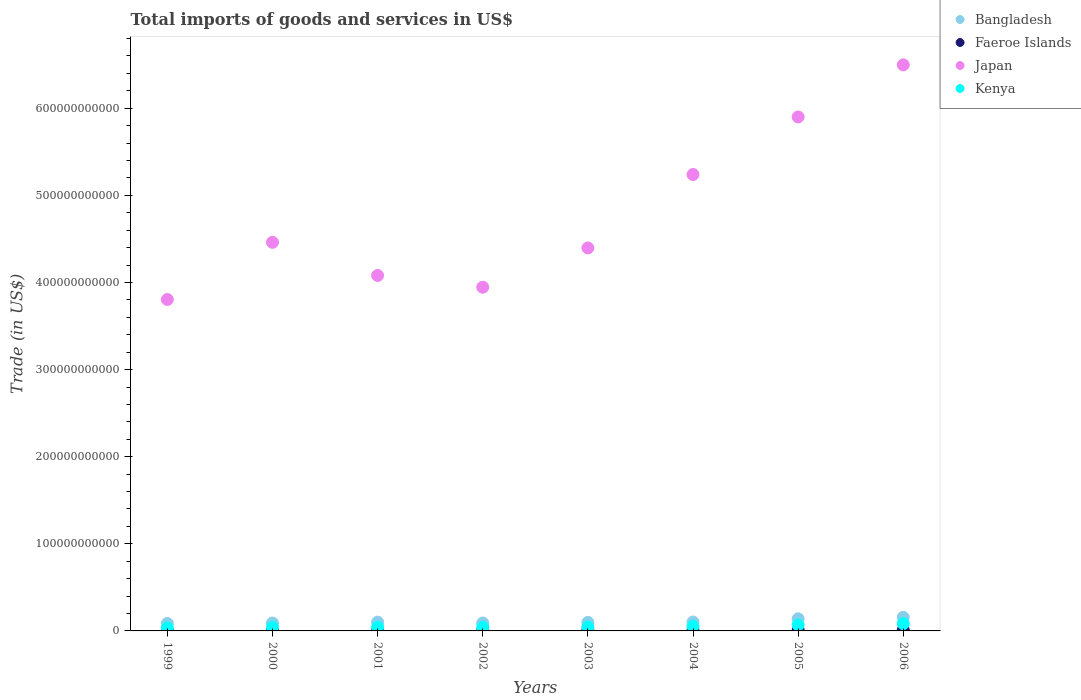What is the total imports of goods and services in Faeroe Islands in 2001?
Provide a succinct answer. 5.85e+08. Across all years, what is the maximum total imports of goods and services in Faeroe Islands?
Provide a succinct answer. 1.03e+09. Across all years, what is the minimum total imports of goods and services in Faeroe Islands?
Your response must be concise. 5.60e+08. In which year was the total imports of goods and services in Bangladesh maximum?
Provide a short and direct response. 2006. What is the total total imports of goods and services in Kenya in the graph?
Ensure brevity in your answer.  4.07e+1. What is the difference between the total imports of goods and services in Bangladesh in 1999 and that in 2000?
Your response must be concise. -5.35e+08. What is the difference between the total imports of goods and services in Japan in 2002 and the total imports of goods and services in Bangladesh in 2005?
Your response must be concise. 3.81e+11. What is the average total imports of goods and services in Kenya per year?
Make the answer very short. 5.08e+09. In the year 2003, what is the difference between the total imports of goods and services in Kenya and total imports of goods and services in Faeroe Islands?
Your response must be concise. 3.61e+09. In how many years, is the total imports of goods and services in Faeroe Islands greater than 560000000000 US$?
Make the answer very short. 0. What is the ratio of the total imports of goods and services in Kenya in 2002 to that in 2006?
Your answer should be compact. 0.48. Is the total imports of goods and services in Japan in 2001 less than that in 2005?
Provide a succinct answer. Yes. What is the difference between the highest and the second highest total imports of goods and services in Kenya?
Your response must be concise. 1.59e+09. What is the difference between the highest and the lowest total imports of goods and services in Japan?
Provide a succinct answer. 2.69e+11. Is the sum of the total imports of goods and services in Japan in 1999 and 2003 greater than the maximum total imports of goods and services in Kenya across all years?
Provide a short and direct response. Yes. Is it the case that in every year, the sum of the total imports of goods and services in Japan and total imports of goods and services in Faeroe Islands  is greater than the total imports of goods and services in Kenya?
Offer a terse response. Yes. Is the total imports of goods and services in Bangladesh strictly greater than the total imports of goods and services in Faeroe Islands over the years?
Give a very brief answer. Yes. How many dotlines are there?
Keep it short and to the point. 4. How many years are there in the graph?
Offer a very short reply. 8. What is the difference between two consecutive major ticks on the Y-axis?
Offer a terse response. 1.00e+11. Are the values on the major ticks of Y-axis written in scientific E-notation?
Your answer should be compact. No. Does the graph contain any zero values?
Give a very brief answer. No. How many legend labels are there?
Your response must be concise. 4. How are the legend labels stacked?
Offer a terse response. Vertical. What is the title of the graph?
Your answer should be compact. Total imports of goods and services in US$. Does "Uganda" appear as one of the legend labels in the graph?
Give a very brief answer. No. What is the label or title of the Y-axis?
Make the answer very short. Trade (in US$). What is the Trade (in US$) of Bangladesh in 1999?
Provide a succinct answer. 8.53e+09. What is the Trade (in US$) of Faeroe Islands in 1999?
Ensure brevity in your answer.  5.60e+08. What is the Trade (in US$) of Japan in 1999?
Your answer should be very brief. 3.80e+11. What is the Trade (in US$) in Kenya in 1999?
Provide a succinct answer. 3.53e+09. What is the Trade (in US$) in Bangladesh in 2000?
Provide a succinct answer. 9.06e+09. What is the Trade (in US$) of Faeroe Islands in 2000?
Your answer should be compact. 6.11e+08. What is the Trade (in US$) of Japan in 2000?
Your response must be concise. 4.46e+11. What is the Trade (in US$) of Kenya in 2000?
Keep it short and to the point. 4.03e+09. What is the Trade (in US$) in Bangladesh in 2001?
Ensure brevity in your answer.  1.01e+1. What is the Trade (in US$) in Faeroe Islands in 2001?
Keep it short and to the point. 5.85e+08. What is the Trade (in US$) of Japan in 2001?
Provide a succinct answer. 4.08e+11. What is the Trade (in US$) of Kenya in 2001?
Offer a very short reply. 4.29e+09. What is the Trade (in US$) of Bangladesh in 2002?
Your answer should be very brief. 9.06e+09. What is the Trade (in US$) of Faeroe Islands in 2002?
Provide a short and direct response. 6.11e+08. What is the Trade (in US$) in Japan in 2002?
Ensure brevity in your answer.  3.95e+11. What is the Trade (in US$) in Kenya in 2002?
Provide a succinct answer. 3.98e+09. What is the Trade (in US$) in Bangladesh in 2003?
Keep it short and to the point. 9.76e+09. What is the Trade (in US$) in Faeroe Islands in 2003?
Give a very brief answer. 8.70e+08. What is the Trade (in US$) of Japan in 2003?
Your answer should be compact. 4.40e+11. What is the Trade (in US$) of Kenya in 2003?
Keep it short and to the point. 4.48e+09. What is the Trade (in US$) in Bangladesh in 2004?
Provide a succinct answer. 1.02e+1. What is the Trade (in US$) of Faeroe Islands in 2004?
Your answer should be very brief. 7.70e+08. What is the Trade (in US$) of Japan in 2004?
Your answer should be very brief. 5.24e+11. What is the Trade (in US$) of Kenya in 2004?
Give a very brief answer. 5.29e+09. What is the Trade (in US$) in Bangladesh in 2005?
Your answer should be very brief. 1.39e+1. What is the Trade (in US$) in Faeroe Islands in 2005?
Offer a terse response. 9.09e+08. What is the Trade (in US$) of Japan in 2005?
Give a very brief answer. 5.90e+11. What is the Trade (in US$) of Kenya in 2005?
Provide a short and direct response. 6.74e+09. What is the Trade (in US$) in Bangladesh in 2006?
Make the answer very short. 1.56e+1. What is the Trade (in US$) in Faeroe Islands in 2006?
Your answer should be very brief. 1.03e+09. What is the Trade (in US$) of Japan in 2006?
Your answer should be compact. 6.50e+11. What is the Trade (in US$) in Kenya in 2006?
Give a very brief answer. 8.33e+09. Across all years, what is the maximum Trade (in US$) in Bangladesh?
Offer a terse response. 1.56e+1. Across all years, what is the maximum Trade (in US$) of Faeroe Islands?
Ensure brevity in your answer.  1.03e+09. Across all years, what is the maximum Trade (in US$) in Japan?
Provide a succinct answer. 6.50e+11. Across all years, what is the maximum Trade (in US$) of Kenya?
Make the answer very short. 8.33e+09. Across all years, what is the minimum Trade (in US$) of Bangladesh?
Provide a short and direct response. 8.53e+09. Across all years, what is the minimum Trade (in US$) of Faeroe Islands?
Provide a succinct answer. 5.60e+08. Across all years, what is the minimum Trade (in US$) of Japan?
Keep it short and to the point. 3.80e+11. Across all years, what is the minimum Trade (in US$) of Kenya?
Provide a succinct answer. 3.53e+09. What is the total Trade (in US$) in Bangladesh in the graph?
Your response must be concise. 8.63e+1. What is the total Trade (in US$) of Faeroe Islands in the graph?
Provide a succinct answer. 5.94e+09. What is the total Trade (in US$) of Japan in the graph?
Your response must be concise. 3.83e+12. What is the total Trade (in US$) of Kenya in the graph?
Your answer should be compact. 4.07e+1. What is the difference between the Trade (in US$) of Bangladesh in 1999 and that in 2000?
Your answer should be compact. -5.35e+08. What is the difference between the Trade (in US$) in Faeroe Islands in 1999 and that in 2000?
Provide a succinct answer. -5.15e+07. What is the difference between the Trade (in US$) of Japan in 1999 and that in 2000?
Your answer should be very brief. -6.56e+1. What is the difference between the Trade (in US$) of Kenya in 1999 and that in 2000?
Offer a terse response. -5.02e+08. What is the difference between the Trade (in US$) of Bangladesh in 1999 and that in 2001?
Your answer should be compact. -1.58e+09. What is the difference between the Trade (in US$) in Faeroe Islands in 1999 and that in 2001?
Offer a very short reply. -2.49e+07. What is the difference between the Trade (in US$) of Japan in 1999 and that in 2001?
Ensure brevity in your answer.  -2.76e+1. What is the difference between the Trade (in US$) in Kenya in 1999 and that in 2001?
Make the answer very short. -7.59e+08. What is the difference between the Trade (in US$) in Bangladesh in 1999 and that in 2002?
Provide a short and direct response. -5.35e+08. What is the difference between the Trade (in US$) in Faeroe Islands in 1999 and that in 2002?
Offer a terse response. -5.10e+07. What is the difference between the Trade (in US$) in Japan in 1999 and that in 2002?
Give a very brief answer. -1.41e+1. What is the difference between the Trade (in US$) of Kenya in 1999 and that in 2002?
Provide a short and direct response. -4.52e+08. What is the difference between the Trade (in US$) of Bangladesh in 1999 and that in 2003?
Offer a very short reply. -1.24e+09. What is the difference between the Trade (in US$) of Faeroe Islands in 1999 and that in 2003?
Make the answer very short. -3.10e+08. What is the difference between the Trade (in US$) in Japan in 1999 and that in 2003?
Provide a succinct answer. -5.92e+1. What is the difference between the Trade (in US$) of Kenya in 1999 and that in 2003?
Your response must be concise. -9.50e+08. What is the difference between the Trade (in US$) in Bangladesh in 1999 and that in 2004?
Offer a terse response. -1.70e+09. What is the difference between the Trade (in US$) in Faeroe Islands in 1999 and that in 2004?
Keep it short and to the point. -2.10e+08. What is the difference between the Trade (in US$) of Japan in 1999 and that in 2004?
Provide a succinct answer. -1.43e+11. What is the difference between the Trade (in US$) in Kenya in 1999 and that in 2004?
Offer a terse response. -1.76e+09. What is the difference between the Trade (in US$) in Bangladesh in 1999 and that in 2005?
Your response must be concise. -5.37e+09. What is the difference between the Trade (in US$) in Faeroe Islands in 1999 and that in 2005?
Provide a succinct answer. -3.49e+08. What is the difference between the Trade (in US$) in Japan in 1999 and that in 2005?
Offer a terse response. -2.10e+11. What is the difference between the Trade (in US$) of Kenya in 1999 and that in 2005?
Give a very brief answer. -3.21e+09. What is the difference between the Trade (in US$) in Bangladesh in 1999 and that in 2006?
Ensure brevity in your answer.  -7.10e+09. What is the difference between the Trade (in US$) of Faeroe Islands in 1999 and that in 2006?
Your answer should be compact. -4.66e+08. What is the difference between the Trade (in US$) of Japan in 1999 and that in 2006?
Ensure brevity in your answer.  -2.69e+11. What is the difference between the Trade (in US$) of Kenya in 1999 and that in 2006?
Keep it short and to the point. -4.80e+09. What is the difference between the Trade (in US$) of Bangladesh in 2000 and that in 2001?
Provide a short and direct response. -1.04e+09. What is the difference between the Trade (in US$) of Faeroe Islands in 2000 and that in 2001?
Your answer should be very brief. 2.66e+07. What is the difference between the Trade (in US$) of Japan in 2000 and that in 2001?
Your response must be concise. 3.80e+1. What is the difference between the Trade (in US$) in Kenya in 2000 and that in 2001?
Ensure brevity in your answer.  -2.57e+08. What is the difference between the Trade (in US$) of Bangladesh in 2000 and that in 2002?
Your answer should be very brief. -2.89e+04. What is the difference between the Trade (in US$) in Faeroe Islands in 2000 and that in 2002?
Make the answer very short. 4.89e+05. What is the difference between the Trade (in US$) of Japan in 2000 and that in 2002?
Make the answer very short. 5.15e+1. What is the difference between the Trade (in US$) of Kenya in 2000 and that in 2002?
Offer a terse response. 4.99e+07. What is the difference between the Trade (in US$) in Bangladesh in 2000 and that in 2003?
Give a very brief answer. -7.01e+08. What is the difference between the Trade (in US$) in Faeroe Islands in 2000 and that in 2003?
Ensure brevity in your answer.  -2.58e+08. What is the difference between the Trade (in US$) of Japan in 2000 and that in 2003?
Give a very brief answer. 6.43e+09. What is the difference between the Trade (in US$) of Kenya in 2000 and that in 2003?
Your answer should be very brief. -4.48e+08. What is the difference between the Trade (in US$) of Bangladesh in 2000 and that in 2004?
Keep it short and to the point. -1.17e+09. What is the difference between the Trade (in US$) of Faeroe Islands in 2000 and that in 2004?
Ensure brevity in your answer.  -1.58e+08. What is the difference between the Trade (in US$) in Japan in 2000 and that in 2004?
Your answer should be compact. -7.78e+1. What is the difference between the Trade (in US$) of Kenya in 2000 and that in 2004?
Provide a succinct answer. -1.26e+09. What is the difference between the Trade (in US$) in Bangladesh in 2000 and that in 2005?
Provide a short and direct response. -4.83e+09. What is the difference between the Trade (in US$) in Faeroe Islands in 2000 and that in 2005?
Ensure brevity in your answer.  -2.97e+08. What is the difference between the Trade (in US$) of Japan in 2000 and that in 2005?
Give a very brief answer. -1.44e+11. What is the difference between the Trade (in US$) in Kenya in 2000 and that in 2005?
Ensure brevity in your answer.  -2.71e+09. What is the difference between the Trade (in US$) of Bangladesh in 2000 and that in 2006?
Make the answer very short. -6.57e+09. What is the difference between the Trade (in US$) in Faeroe Islands in 2000 and that in 2006?
Offer a very short reply. -4.14e+08. What is the difference between the Trade (in US$) in Japan in 2000 and that in 2006?
Give a very brief answer. -2.04e+11. What is the difference between the Trade (in US$) in Kenya in 2000 and that in 2006?
Keep it short and to the point. -4.30e+09. What is the difference between the Trade (in US$) in Bangladesh in 2001 and that in 2002?
Offer a terse response. 1.04e+09. What is the difference between the Trade (in US$) in Faeroe Islands in 2001 and that in 2002?
Provide a succinct answer. -2.61e+07. What is the difference between the Trade (in US$) in Japan in 2001 and that in 2002?
Your answer should be compact. 1.35e+1. What is the difference between the Trade (in US$) in Kenya in 2001 and that in 2002?
Your response must be concise. 3.07e+08. What is the difference between the Trade (in US$) in Bangladesh in 2001 and that in 2003?
Keep it short and to the point. 3.41e+08. What is the difference between the Trade (in US$) in Faeroe Islands in 2001 and that in 2003?
Provide a short and direct response. -2.85e+08. What is the difference between the Trade (in US$) of Japan in 2001 and that in 2003?
Your response must be concise. -3.16e+1. What is the difference between the Trade (in US$) in Kenya in 2001 and that in 2003?
Offer a terse response. -1.91e+08. What is the difference between the Trade (in US$) of Bangladesh in 2001 and that in 2004?
Keep it short and to the point. -1.27e+08. What is the difference between the Trade (in US$) of Faeroe Islands in 2001 and that in 2004?
Your answer should be compact. -1.85e+08. What is the difference between the Trade (in US$) of Japan in 2001 and that in 2004?
Your answer should be compact. -1.16e+11. What is the difference between the Trade (in US$) in Kenya in 2001 and that in 2004?
Provide a short and direct response. -1.00e+09. What is the difference between the Trade (in US$) in Bangladesh in 2001 and that in 2005?
Provide a short and direct response. -3.79e+09. What is the difference between the Trade (in US$) in Faeroe Islands in 2001 and that in 2005?
Ensure brevity in your answer.  -3.24e+08. What is the difference between the Trade (in US$) of Japan in 2001 and that in 2005?
Offer a terse response. -1.82e+11. What is the difference between the Trade (in US$) of Kenya in 2001 and that in 2005?
Provide a succinct answer. -2.45e+09. What is the difference between the Trade (in US$) of Bangladesh in 2001 and that in 2006?
Your answer should be compact. -5.52e+09. What is the difference between the Trade (in US$) in Faeroe Islands in 2001 and that in 2006?
Your answer should be very brief. -4.41e+08. What is the difference between the Trade (in US$) of Japan in 2001 and that in 2006?
Offer a very short reply. -2.42e+11. What is the difference between the Trade (in US$) in Kenya in 2001 and that in 2006?
Provide a succinct answer. -4.04e+09. What is the difference between the Trade (in US$) in Bangladesh in 2002 and that in 2003?
Provide a succinct answer. -7.01e+08. What is the difference between the Trade (in US$) of Faeroe Islands in 2002 and that in 2003?
Your response must be concise. -2.59e+08. What is the difference between the Trade (in US$) of Japan in 2002 and that in 2003?
Ensure brevity in your answer.  -4.51e+1. What is the difference between the Trade (in US$) of Kenya in 2002 and that in 2003?
Make the answer very short. -4.98e+08. What is the difference between the Trade (in US$) of Bangladesh in 2002 and that in 2004?
Your answer should be very brief. -1.17e+09. What is the difference between the Trade (in US$) in Faeroe Islands in 2002 and that in 2004?
Keep it short and to the point. -1.59e+08. What is the difference between the Trade (in US$) in Japan in 2002 and that in 2004?
Give a very brief answer. -1.29e+11. What is the difference between the Trade (in US$) in Kenya in 2002 and that in 2004?
Keep it short and to the point. -1.31e+09. What is the difference between the Trade (in US$) of Bangladesh in 2002 and that in 2005?
Provide a short and direct response. -4.83e+09. What is the difference between the Trade (in US$) in Faeroe Islands in 2002 and that in 2005?
Your response must be concise. -2.98e+08. What is the difference between the Trade (in US$) of Japan in 2002 and that in 2005?
Your response must be concise. -1.95e+11. What is the difference between the Trade (in US$) of Kenya in 2002 and that in 2005?
Give a very brief answer. -2.76e+09. What is the difference between the Trade (in US$) in Bangladesh in 2002 and that in 2006?
Your answer should be very brief. -6.57e+09. What is the difference between the Trade (in US$) of Faeroe Islands in 2002 and that in 2006?
Provide a succinct answer. -4.15e+08. What is the difference between the Trade (in US$) in Japan in 2002 and that in 2006?
Ensure brevity in your answer.  -2.55e+11. What is the difference between the Trade (in US$) of Kenya in 2002 and that in 2006?
Provide a succinct answer. -4.35e+09. What is the difference between the Trade (in US$) in Bangladesh in 2003 and that in 2004?
Your answer should be compact. -4.68e+08. What is the difference between the Trade (in US$) in Faeroe Islands in 2003 and that in 2004?
Provide a short and direct response. 1.00e+08. What is the difference between the Trade (in US$) in Japan in 2003 and that in 2004?
Provide a short and direct response. -8.43e+1. What is the difference between the Trade (in US$) in Kenya in 2003 and that in 2004?
Offer a very short reply. -8.12e+08. What is the difference between the Trade (in US$) in Bangladesh in 2003 and that in 2005?
Ensure brevity in your answer.  -4.13e+09. What is the difference between the Trade (in US$) in Faeroe Islands in 2003 and that in 2005?
Your answer should be very brief. -3.90e+07. What is the difference between the Trade (in US$) in Japan in 2003 and that in 2005?
Your response must be concise. -1.50e+11. What is the difference between the Trade (in US$) of Kenya in 2003 and that in 2005?
Give a very brief answer. -2.26e+09. What is the difference between the Trade (in US$) in Bangladesh in 2003 and that in 2006?
Offer a terse response. -5.86e+09. What is the difference between the Trade (in US$) of Faeroe Islands in 2003 and that in 2006?
Make the answer very short. -1.56e+08. What is the difference between the Trade (in US$) of Japan in 2003 and that in 2006?
Make the answer very short. -2.10e+11. What is the difference between the Trade (in US$) in Kenya in 2003 and that in 2006?
Provide a short and direct response. -3.85e+09. What is the difference between the Trade (in US$) of Bangladesh in 2004 and that in 2005?
Your response must be concise. -3.66e+09. What is the difference between the Trade (in US$) of Faeroe Islands in 2004 and that in 2005?
Give a very brief answer. -1.39e+08. What is the difference between the Trade (in US$) in Japan in 2004 and that in 2005?
Offer a terse response. -6.61e+1. What is the difference between the Trade (in US$) in Kenya in 2004 and that in 2005?
Offer a very short reply. -1.45e+09. What is the difference between the Trade (in US$) in Bangladesh in 2004 and that in 2006?
Your answer should be compact. -5.40e+09. What is the difference between the Trade (in US$) in Faeroe Islands in 2004 and that in 2006?
Provide a short and direct response. -2.56e+08. What is the difference between the Trade (in US$) in Japan in 2004 and that in 2006?
Provide a short and direct response. -1.26e+11. What is the difference between the Trade (in US$) in Kenya in 2004 and that in 2006?
Provide a short and direct response. -3.04e+09. What is the difference between the Trade (in US$) of Bangladesh in 2005 and that in 2006?
Keep it short and to the point. -1.74e+09. What is the difference between the Trade (in US$) of Faeroe Islands in 2005 and that in 2006?
Give a very brief answer. -1.17e+08. What is the difference between the Trade (in US$) of Japan in 2005 and that in 2006?
Make the answer very short. -5.98e+1. What is the difference between the Trade (in US$) of Kenya in 2005 and that in 2006?
Provide a succinct answer. -1.59e+09. What is the difference between the Trade (in US$) of Bangladesh in 1999 and the Trade (in US$) of Faeroe Islands in 2000?
Provide a short and direct response. 7.91e+09. What is the difference between the Trade (in US$) in Bangladesh in 1999 and the Trade (in US$) in Japan in 2000?
Your response must be concise. -4.38e+11. What is the difference between the Trade (in US$) in Bangladesh in 1999 and the Trade (in US$) in Kenya in 2000?
Ensure brevity in your answer.  4.50e+09. What is the difference between the Trade (in US$) of Faeroe Islands in 1999 and the Trade (in US$) of Japan in 2000?
Ensure brevity in your answer.  -4.46e+11. What is the difference between the Trade (in US$) of Faeroe Islands in 1999 and the Trade (in US$) of Kenya in 2000?
Give a very brief answer. -3.47e+09. What is the difference between the Trade (in US$) of Japan in 1999 and the Trade (in US$) of Kenya in 2000?
Give a very brief answer. 3.76e+11. What is the difference between the Trade (in US$) of Bangladesh in 1999 and the Trade (in US$) of Faeroe Islands in 2001?
Your answer should be very brief. 7.94e+09. What is the difference between the Trade (in US$) in Bangladesh in 1999 and the Trade (in US$) in Japan in 2001?
Offer a very short reply. -4.00e+11. What is the difference between the Trade (in US$) of Bangladesh in 1999 and the Trade (in US$) of Kenya in 2001?
Your answer should be compact. 4.24e+09. What is the difference between the Trade (in US$) of Faeroe Islands in 1999 and the Trade (in US$) of Japan in 2001?
Provide a short and direct response. -4.07e+11. What is the difference between the Trade (in US$) in Faeroe Islands in 1999 and the Trade (in US$) in Kenya in 2001?
Offer a very short reply. -3.73e+09. What is the difference between the Trade (in US$) in Japan in 1999 and the Trade (in US$) in Kenya in 2001?
Keep it short and to the point. 3.76e+11. What is the difference between the Trade (in US$) of Bangladesh in 1999 and the Trade (in US$) of Faeroe Islands in 2002?
Give a very brief answer. 7.92e+09. What is the difference between the Trade (in US$) in Bangladesh in 1999 and the Trade (in US$) in Japan in 2002?
Offer a terse response. -3.86e+11. What is the difference between the Trade (in US$) of Bangladesh in 1999 and the Trade (in US$) of Kenya in 2002?
Offer a terse response. 4.55e+09. What is the difference between the Trade (in US$) of Faeroe Islands in 1999 and the Trade (in US$) of Japan in 2002?
Offer a very short reply. -3.94e+11. What is the difference between the Trade (in US$) of Faeroe Islands in 1999 and the Trade (in US$) of Kenya in 2002?
Make the answer very short. -3.42e+09. What is the difference between the Trade (in US$) of Japan in 1999 and the Trade (in US$) of Kenya in 2002?
Offer a very short reply. 3.76e+11. What is the difference between the Trade (in US$) of Bangladesh in 1999 and the Trade (in US$) of Faeroe Islands in 2003?
Give a very brief answer. 7.66e+09. What is the difference between the Trade (in US$) of Bangladesh in 1999 and the Trade (in US$) of Japan in 2003?
Keep it short and to the point. -4.31e+11. What is the difference between the Trade (in US$) of Bangladesh in 1999 and the Trade (in US$) of Kenya in 2003?
Provide a succinct answer. 4.05e+09. What is the difference between the Trade (in US$) in Faeroe Islands in 1999 and the Trade (in US$) in Japan in 2003?
Provide a short and direct response. -4.39e+11. What is the difference between the Trade (in US$) of Faeroe Islands in 1999 and the Trade (in US$) of Kenya in 2003?
Your response must be concise. -3.92e+09. What is the difference between the Trade (in US$) of Japan in 1999 and the Trade (in US$) of Kenya in 2003?
Your response must be concise. 3.76e+11. What is the difference between the Trade (in US$) in Bangladesh in 1999 and the Trade (in US$) in Faeroe Islands in 2004?
Your answer should be very brief. 7.76e+09. What is the difference between the Trade (in US$) in Bangladesh in 1999 and the Trade (in US$) in Japan in 2004?
Your response must be concise. -5.15e+11. What is the difference between the Trade (in US$) in Bangladesh in 1999 and the Trade (in US$) in Kenya in 2004?
Ensure brevity in your answer.  3.24e+09. What is the difference between the Trade (in US$) in Faeroe Islands in 1999 and the Trade (in US$) in Japan in 2004?
Offer a very short reply. -5.23e+11. What is the difference between the Trade (in US$) in Faeroe Islands in 1999 and the Trade (in US$) in Kenya in 2004?
Keep it short and to the point. -4.73e+09. What is the difference between the Trade (in US$) in Japan in 1999 and the Trade (in US$) in Kenya in 2004?
Provide a succinct answer. 3.75e+11. What is the difference between the Trade (in US$) in Bangladesh in 1999 and the Trade (in US$) in Faeroe Islands in 2005?
Your answer should be very brief. 7.62e+09. What is the difference between the Trade (in US$) in Bangladesh in 1999 and the Trade (in US$) in Japan in 2005?
Your answer should be very brief. -5.81e+11. What is the difference between the Trade (in US$) in Bangladesh in 1999 and the Trade (in US$) in Kenya in 2005?
Ensure brevity in your answer.  1.79e+09. What is the difference between the Trade (in US$) of Faeroe Islands in 1999 and the Trade (in US$) of Japan in 2005?
Keep it short and to the point. -5.89e+11. What is the difference between the Trade (in US$) in Faeroe Islands in 1999 and the Trade (in US$) in Kenya in 2005?
Give a very brief answer. -6.18e+09. What is the difference between the Trade (in US$) in Japan in 1999 and the Trade (in US$) in Kenya in 2005?
Provide a short and direct response. 3.74e+11. What is the difference between the Trade (in US$) in Bangladesh in 1999 and the Trade (in US$) in Faeroe Islands in 2006?
Provide a succinct answer. 7.50e+09. What is the difference between the Trade (in US$) of Bangladesh in 1999 and the Trade (in US$) of Japan in 2006?
Keep it short and to the point. -6.41e+11. What is the difference between the Trade (in US$) of Bangladesh in 1999 and the Trade (in US$) of Kenya in 2006?
Your response must be concise. 1.97e+08. What is the difference between the Trade (in US$) in Faeroe Islands in 1999 and the Trade (in US$) in Japan in 2006?
Make the answer very short. -6.49e+11. What is the difference between the Trade (in US$) in Faeroe Islands in 1999 and the Trade (in US$) in Kenya in 2006?
Make the answer very short. -7.77e+09. What is the difference between the Trade (in US$) of Japan in 1999 and the Trade (in US$) of Kenya in 2006?
Provide a short and direct response. 3.72e+11. What is the difference between the Trade (in US$) in Bangladesh in 2000 and the Trade (in US$) in Faeroe Islands in 2001?
Ensure brevity in your answer.  8.48e+09. What is the difference between the Trade (in US$) in Bangladesh in 2000 and the Trade (in US$) in Japan in 2001?
Make the answer very short. -3.99e+11. What is the difference between the Trade (in US$) in Bangladesh in 2000 and the Trade (in US$) in Kenya in 2001?
Your answer should be very brief. 4.77e+09. What is the difference between the Trade (in US$) in Faeroe Islands in 2000 and the Trade (in US$) in Japan in 2001?
Provide a short and direct response. -4.07e+11. What is the difference between the Trade (in US$) in Faeroe Islands in 2000 and the Trade (in US$) in Kenya in 2001?
Provide a succinct answer. -3.68e+09. What is the difference between the Trade (in US$) in Japan in 2000 and the Trade (in US$) in Kenya in 2001?
Make the answer very short. 4.42e+11. What is the difference between the Trade (in US$) of Bangladesh in 2000 and the Trade (in US$) of Faeroe Islands in 2002?
Offer a very short reply. 8.45e+09. What is the difference between the Trade (in US$) in Bangladesh in 2000 and the Trade (in US$) in Japan in 2002?
Your response must be concise. -3.85e+11. What is the difference between the Trade (in US$) in Bangladesh in 2000 and the Trade (in US$) in Kenya in 2002?
Ensure brevity in your answer.  5.08e+09. What is the difference between the Trade (in US$) in Faeroe Islands in 2000 and the Trade (in US$) in Japan in 2002?
Make the answer very short. -3.94e+11. What is the difference between the Trade (in US$) in Faeroe Islands in 2000 and the Trade (in US$) in Kenya in 2002?
Make the answer very short. -3.37e+09. What is the difference between the Trade (in US$) of Japan in 2000 and the Trade (in US$) of Kenya in 2002?
Ensure brevity in your answer.  4.42e+11. What is the difference between the Trade (in US$) in Bangladesh in 2000 and the Trade (in US$) in Faeroe Islands in 2003?
Offer a very short reply. 8.19e+09. What is the difference between the Trade (in US$) of Bangladesh in 2000 and the Trade (in US$) of Japan in 2003?
Give a very brief answer. -4.31e+11. What is the difference between the Trade (in US$) of Bangladesh in 2000 and the Trade (in US$) of Kenya in 2003?
Provide a succinct answer. 4.58e+09. What is the difference between the Trade (in US$) in Faeroe Islands in 2000 and the Trade (in US$) in Japan in 2003?
Provide a short and direct response. -4.39e+11. What is the difference between the Trade (in US$) in Faeroe Islands in 2000 and the Trade (in US$) in Kenya in 2003?
Provide a succinct answer. -3.87e+09. What is the difference between the Trade (in US$) in Japan in 2000 and the Trade (in US$) in Kenya in 2003?
Provide a short and direct response. 4.42e+11. What is the difference between the Trade (in US$) of Bangladesh in 2000 and the Trade (in US$) of Faeroe Islands in 2004?
Provide a short and direct response. 8.29e+09. What is the difference between the Trade (in US$) in Bangladesh in 2000 and the Trade (in US$) in Japan in 2004?
Your answer should be compact. -5.15e+11. What is the difference between the Trade (in US$) of Bangladesh in 2000 and the Trade (in US$) of Kenya in 2004?
Make the answer very short. 3.77e+09. What is the difference between the Trade (in US$) of Faeroe Islands in 2000 and the Trade (in US$) of Japan in 2004?
Ensure brevity in your answer.  -5.23e+11. What is the difference between the Trade (in US$) in Faeroe Islands in 2000 and the Trade (in US$) in Kenya in 2004?
Provide a succinct answer. -4.68e+09. What is the difference between the Trade (in US$) in Japan in 2000 and the Trade (in US$) in Kenya in 2004?
Offer a terse response. 4.41e+11. What is the difference between the Trade (in US$) in Bangladesh in 2000 and the Trade (in US$) in Faeroe Islands in 2005?
Give a very brief answer. 8.15e+09. What is the difference between the Trade (in US$) in Bangladesh in 2000 and the Trade (in US$) in Japan in 2005?
Your answer should be compact. -5.81e+11. What is the difference between the Trade (in US$) in Bangladesh in 2000 and the Trade (in US$) in Kenya in 2005?
Your answer should be compact. 2.32e+09. What is the difference between the Trade (in US$) of Faeroe Islands in 2000 and the Trade (in US$) of Japan in 2005?
Offer a terse response. -5.89e+11. What is the difference between the Trade (in US$) of Faeroe Islands in 2000 and the Trade (in US$) of Kenya in 2005?
Keep it short and to the point. -6.13e+09. What is the difference between the Trade (in US$) in Japan in 2000 and the Trade (in US$) in Kenya in 2005?
Provide a succinct answer. 4.39e+11. What is the difference between the Trade (in US$) in Bangladesh in 2000 and the Trade (in US$) in Faeroe Islands in 2006?
Keep it short and to the point. 8.04e+09. What is the difference between the Trade (in US$) in Bangladesh in 2000 and the Trade (in US$) in Japan in 2006?
Provide a short and direct response. -6.41e+11. What is the difference between the Trade (in US$) of Bangladesh in 2000 and the Trade (in US$) of Kenya in 2006?
Provide a succinct answer. 7.32e+08. What is the difference between the Trade (in US$) in Faeroe Islands in 2000 and the Trade (in US$) in Japan in 2006?
Your answer should be compact. -6.49e+11. What is the difference between the Trade (in US$) of Faeroe Islands in 2000 and the Trade (in US$) of Kenya in 2006?
Offer a very short reply. -7.72e+09. What is the difference between the Trade (in US$) of Japan in 2000 and the Trade (in US$) of Kenya in 2006?
Your response must be concise. 4.38e+11. What is the difference between the Trade (in US$) of Bangladesh in 2001 and the Trade (in US$) of Faeroe Islands in 2002?
Make the answer very short. 9.49e+09. What is the difference between the Trade (in US$) of Bangladesh in 2001 and the Trade (in US$) of Japan in 2002?
Provide a short and direct response. -3.84e+11. What is the difference between the Trade (in US$) in Bangladesh in 2001 and the Trade (in US$) in Kenya in 2002?
Your answer should be compact. 6.12e+09. What is the difference between the Trade (in US$) of Faeroe Islands in 2001 and the Trade (in US$) of Japan in 2002?
Give a very brief answer. -3.94e+11. What is the difference between the Trade (in US$) in Faeroe Islands in 2001 and the Trade (in US$) in Kenya in 2002?
Ensure brevity in your answer.  -3.40e+09. What is the difference between the Trade (in US$) of Japan in 2001 and the Trade (in US$) of Kenya in 2002?
Provide a succinct answer. 4.04e+11. What is the difference between the Trade (in US$) in Bangladesh in 2001 and the Trade (in US$) in Faeroe Islands in 2003?
Your answer should be compact. 9.23e+09. What is the difference between the Trade (in US$) of Bangladesh in 2001 and the Trade (in US$) of Japan in 2003?
Keep it short and to the point. -4.30e+11. What is the difference between the Trade (in US$) of Bangladesh in 2001 and the Trade (in US$) of Kenya in 2003?
Make the answer very short. 5.62e+09. What is the difference between the Trade (in US$) of Faeroe Islands in 2001 and the Trade (in US$) of Japan in 2003?
Offer a very short reply. -4.39e+11. What is the difference between the Trade (in US$) in Faeroe Islands in 2001 and the Trade (in US$) in Kenya in 2003?
Ensure brevity in your answer.  -3.89e+09. What is the difference between the Trade (in US$) of Japan in 2001 and the Trade (in US$) of Kenya in 2003?
Your response must be concise. 4.04e+11. What is the difference between the Trade (in US$) of Bangladesh in 2001 and the Trade (in US$) of Faeroe Islands in 2004?
Provide a short and direct response. 9.33e+09. What is the difference between the Trade (in US$) in Bangladesh in 2001 and the Trade (in US$) in Japan in 2004?
Your answer should be very brief. -5.14e+11. What is the difference between the Trade (in US$) of Bangladesh in 2001 and the Trade (in US$) of Kenya in 2004?
Keep it short and to the point. 4.81e+09. What is the difference between the Trade (in US$) in Faeroe Islands in 2001 and the Trade (in US$) in Japan in 2004?
Provide a short and direct response. -5.23e+11. What is the difference between the Trade (in US$) of Faeroe Islands in 2001 and the Trade (in US$) of Kenya in 2004?
Your response must be concise. -4.71e+09. What is the difference between the Trade (in US$) in Japan in 2001 and the Trade (in US$) in Kenya in 2004?
Provide a succinct answer. 4.03e+11. What is the difference between the Trade (in US$) of Bangladesh in 2001 and the Trade (in US$) of Faeroe Islands in 2005?
Offer a very short reply. 9.19e+09. What is the difference between the Trade (in US$) of Bangladesh in 2001 and the Trade (in US$) of Japan in 2005?
Offer a terse response. -5.80e+11. What is the difference between the Trade (in US$) of Bangladesh in 2001 and the Trade (in US$) of Kenya in 2005?
Your response must be concise. 3.36e+09. What is the difference between the Trade (in US$) in Faeroe Islands in 2001 and the Trade (in US$) in Japan in 2005?
Offer a terse response. -5.89e+11. What is the difference between the Trade (in US$) of Faeroe Islands in 2001 and the Trade (in US$) of Kenya in 2005?
Offer a very short reply. -6.16e+09. What is the difference between the Trade (in US$) of Japan in 2001 and the Trade (in US$) of Kenya in 2005?
Make the answer very short. 4.01e+11. What is the difference between the Trade (in US$) of Bangladesh in 2001 and the Trade (in US$) of Faeroe Islands in 2006?
Provide a short and direct response. 9.08e+09. What is the difference between the Trade (in US$) in Bangladesh in 2001 and the Trade (in US$) in Japan in 2006?
Provide a succinct answer. -6.40e+11. What is the difference between the Trade (in US$) of Bangladesh in 2001 and the Trade (in US$) of Kenya in 2006?
Your answer should be very brief. 1.77e+09. What is the difference between the Trade (in US$) of Faeroe Islands in 2001 and the Trade (in US$) of Japan in 2006?
Provide a short and direct response. -6.49e+11. What is the difference between the Trade (in US$) of Faeroe Islands in 2001 and the Trade (in US$) of Kenya in 2006?
Make the answer very short. -7.74e+09. What is the difference between the Trade (in US$) in Japan in 2001 and the Trade (in US$) in Kenya in 2006?
Your answer should be very brief. 4.00e+11. What is the difference between the Trade (in US$) in Bangladesh in 2002 and the Trade (in US$) in Faeroe Islands in 2003?
Your answer should be very brief. 8.19e+09. What is the difference between the Trade (in US$) of Bangladesh in 2002 and the Trade (in US$) of Japan in 2003?
Provide a succinct answer. -4.31e+11. What is the difference between the Trade (in US$) in Bangladesh in 2002 and the Trade (in US$) in Kenya in 2003?
Your answer should be compact. 4.58e+09. What is the difference between the Trade (in US$) in Faeroe Islands in 2002 and the Trade (in US$) in Japan in 2003?
Provide a short and direct response. -4.39e+11. What is the difference between the Trade (in US$) of Faeroe Islands in 2002 and the Trade (in US$) of Kenya in 2003?
Ensure brevity in your answer.  -3.87e+09. What is the difference between the Trade (in US$) of Japan in 2002 and the Trade (in US$) of Kenya in 2003?
Keep it short and to the point. 3.90e+11. What is the difference between the Trade (in US$) in Bangladesh in 2002 and the Trade (in US$) in Faeroe Islands in 2004?
Give a very brief answer. 8.29e+09. What is the difference between the Trade (in US$) of Bangladesh in 2002 and the Trade (in US$) of Japan in 2004?
Offer a very short reply. -5.15e+11. What is the difference between the Trade (in US$) in Bangladesh in 2002 and the Trade (in US$) in Kenya in 2004?
Ensure brevity in your answer.  3.77e+09. What is the difference between the Trade (in US$) of Faeroe Islands in 2002 and the Trade (in US$) of Japan in 2004?
Provide a succinct answer. -5.23e+11. What is the difference between the Trade (in US$) of Faeroe Islands in 2002 and the Trade (in US$) of Kenya in 2004?
Ensure brevity in your answer.  -4.68e+09. What is the difference between the Trade (in US$) of Japan in 2002 and the Trade (in US$) of Kenya in 2004?
Keep it short and to the point. 3.89e+11. What is the difference between the Trade (in US$) in Bangladesh in 2002 and the Trade (in US$) in Faeroe Islands in 2005?
Your answer should be very brief. 8.15e+09. What is the difference between the Trade (in US$) of Bangladesh in 2002 and the Trade (in US$) of Japan in 2005?
Offer a very short reply. -5.81e+11. What is the difference between the Trade (in US$) of Bangladesh in 2002 and the Trade (in US$) of Kenya in 2005?
Make the answer very short. 2.32e+09. What is the difference between the Trade (in US$) of Faeroe Islands in 2002 and the Trade (in US$) of Japan in 2005?
Offer a terse response. -5.89e+11. What is the difference between the Trade (in US$) in Faeroe Islands in 2002 and the Trade (in US$) in Kenya in 2005?
Offer a very short reply. -6.13e+09. What is the difference between the Trade (in US$) of Japan in 2002 and the Trade (in US$) of Kenya in 2005?
Offer a very short reply. 3.88e+11. What is the difference between the Trade (in US$) of Bangladesh in 2002 and the Trade (in US$) of Faeroe Islands in 2006?
Your answer should be compact. 8.04e+09. What is the difference between the Trade (in US$) in Bangladesh in 2002 and the Trade (in US$) in Japan in 2006?
Keep it short and to the point. -6.41e+11. What is the difference between the Trade (in US$) in Bangladesh in 2002 and the Trade (in US$) in Kenya in 2006?
Keep it short and to the point. 7.32e+08. What is the difference between the Trade (in US$) of Faeroe Islands in 2002 and the Trade (in US$) of Japan in 2006?
Your answer should be compact. -6.49e+11. What is the difference between the Trade (in US$) of Faeroe Islands in 2002 and the Trade (in US$) of Kenya in 2006?
Ensure brevity in your answer.  -7.72e+09. What is the difference between the Trade (in US$) of Japan in 2002 and the Trade (in US$) of Kenya in 2006?
Make the answer very short. 3.86e+11. What is the difference between the Trade (in US$) in Bangladesh in 2003 and the Trade (in US$) in Faeroe Islands in 2004?
Give a very brief answer. 8.99e+09. What is the difference between the Trade (in US$) of Bangladesh in 2003 and the Trade (in US$) of Japan in 2004?
Your response must be concise. -5.14e+11. What is the difference between the Trade (in US$) of Bangladesh in 2003 and the Trade (in US$) of Kenya in 2004?
Give a very brief answer. 4.47e+09. What is the difference between the Trade (in US$) of Faeroe Islands in 2003 and the Trade (in US$) of Japan in 2004?
Your response must be concise. -5.23e+11. What is the difference between the Trade (in US$) in Faeroe Islands in 2003 and the Trade (in US$) in Kenya in 2004?
Offer a terse response. -4.42e+09. What is the difference between the Trade (in US$) in Japan in 2003 and the Trade (in US$) in Kenya in 2004?
Provide a succinct answer. 4.34e+11. What is the difference between the Trade (in US$) of Bangladesh in 2003 and the Trade (in US$) of Faeroe Islands in 2005?
Offer a terse response. 8.85e+09. What is the difference between the Trade (in US$) in Bangladesh in 2003 and the Trade (in US$) in Japan in 2005?
Give a very brief answer. -5.80e+11. What is the difference between the Trade (in US$) of Bangladesh in 2003 and the Trade (in US$) of Kenya in 2005?
Your answer should be very brief. 3.02e+09. What is the difference between the Trade (in US$) in Faeroe Islands in 2003 and the Trade (in US$) in Japan in 2005?
Keep it short and to the point. -5.89e+11. What is the difference between the Trade (in US$) in Faeroe Islands in 2003 and the Trade (in US$) in Kenya in 2005?
Your response must be concise. -5.87e+09. What is the difference between the Trade (in US$) of Japan in 2003 and the Trade (in US$) of Kenya in 2005?
Your answer should be compact. 4.33e+11. What is the difference between the Trade (in US$) of Bangladesh in 2003 and the Trade (in US$) of Faeroe Islands in 2006?
Your answer should be compact. 8.74e+09. What is the difference between the Trade (in US$) of Bangladesh in 2003 and the Trade (in US$) of Japan in 2006?
Your response must be concise. -6.40e+11. What is the difference between the Trade (in US$) in Bangladesh in 2003 and the Trade (in US$) in Kenya in 2006?
Provide a succinct answer. 1.43e+09. What is the difference between the Trade (in US$) in Faeroe Islands in 2003 and the Trade (in US$) in Japan in 2006?
Your answer should be very brief. -6.49e+11. What is the difference between the Trade (in US$) of Faeroe Islands in 2003 and the Trade (in US$) of Kenya in 2006?
Provide a short and direct response. -7.46e+09. What is the difference between the Trade (in US$) in Japan in 2003 and the Trade (in US$) in Kenya in 2006?
Give a very brief answer. 4.31e+11. What is the difference between the Trade (in US$) of Bangladesh in 2004 and the Trade (in US$) of Faeroe Islands in 2005?
Offer a very short reply. 9.32e+09. What is the difference between the Trade (in US$) in Bangladesh in 2004 and the Trade (in US$) in Japan in 2005?
Offer a very short reply. -5.80e+11. What is the difference between the Trade (in US$) in Bangladesh in 2004 and the Trade (in US$) in Kenya in 2005?
Offer a terse response. 3.49e+09. What is the difference between the Trade (in US$) of Faeroe Islands in 2004 and the Trade (in US$) of Japan in 2005?
Keep it short and to the point. -5.89e+11. What is the difference between the Trade (in US$) in Faeroe Islands in 2004 and the Trade (in US$) in Kenya in 2005?
Make the answer very short. -5.97e+09. What is the difference between the Trade (in US$) of Japan in 2004 and the Trade (in US$) of Kenya in 2005?
Keep it short and to the point. 5.17e+11. What is the difference between the Trade (in US$) of Bangladesh in 2004 and the Trade (in US$) of Faeroe Islands in 2006?
Give a very brief answer. 9.20e+09. What is the difference between the Trade (in US$) of Bangladesh in 2004 and the Trade (in US$) of Japan in 2006?
Ensure brevity in your answer.  -6.40e+11. What is the difference between the Trade (in US$) of Bangladesh in 2004 and the Trade (in US$) of Kenya in 2006?
Offer a terse response. 1.90e+09. What is the difference between the Trade (in US$) in Faeroe Islands in 2004 and the Trade (in US$) in Japan in 2006?
Your answer should be compact. -6.49e+11. What is the difference between the Trade (in US$) of Faeroe Islands in 2004 and the Trade (in US$) of Kenya in 2006?
Your answer should be compact. -7.56e+09. What is the difference between the Trade (in US$) of Japan in 2004 and the Trade (in US$) of Kenya in 2006?
Keep it short and to the point. 5.16e+11. What is the difference between the Trade (in US$) in Bangladesh in 2005 and the Trade (in US$) in Faeroe Islands in 2006?
Your response must be concise. 1.29e+1. What is the difference between the Trade (in US$) of Bangladesh in 2005 and the Trade (in US$) of Japan in 2006?
Keep it short and to the point. -6.36e+11. What is the difference between the Trade (in US$) of Bangladesh in 2005 and the Trade (in US$) of Kenya in 2006?
Make the answer very short. 5.56e+09. What is the difference between the Trade (in US$) in Faeroe Islands in 2005 and the Trade (in US$) in Japan in 2006?
Ensure brevity in your answer.  -6.49e+11. What is the difference between the Trade (in US$) of Faeroe Islands in 2005 and the Trade (in US$) of Kenya in 2006?
Provide a succinct answer. -7.42e+09. What is the difference between the Trade (in US$) in Japan in 2005 and the Trade (in US$) in Kenya in 2006?
Ensure brevity in your answer.  5.82e+11. What is the average Trade (in US$) in Bangladesh per year?
Keep it short and to the point. 1.08e+1. What is the average Trade (in US$) in Faeroe Islands per year?
Your answer should be very brief. 7.42e+08. What is the average Trade (in US$) of Japan per year?
Keep it short and to the point. 4.79e+11. What is the average Trade (in US$) of Kenya per year?
Keep it short and to the point. 5.08e+09. In the year 1999, what is the difference between the Trade (in US$) in Bangladesh and Trade (in US$) in Faeroe Islands?
Ensure brevity in your answer.  7.97e+09. In the year 1999, what is the difference between the Trade (in US$) of Bangladesh and Trade (in US$) of Japan?
Keep it short and to the point. -3.72e+11. In the year 1999, what is the difference between the Trade (in US$) of Bangladesh and Trade (in US$) of Kenya?
Your answer should be very brief. 5.00e+09. In the year 1999, what is the difference between the Trade (in US$) in Faeroe Islands and Trade (in US$) in Japan?
Keep it short and to the point. -3.80e+11. In the year 1999, what is the difference between the Trade (in US$) in Faeroe Islands and Trade (in US$) in Kenya?
Your answer should be very brief. -2.97e+09. In the year 1999, what is the difference between the Trade (in US$) of Japan and Trade (in US$) of Kenya?
Your answer should be compact. 3.77e+11. In the year 2000, what is the difference between the Trade (in US$) in Bangladesh and Trade (in US$) in Faeroe Islands?
Your answer should be compact. 8.45e+09. In the year 2000, what is the difference between the Trade (in US$) of Bangladesh and Trade (in US$) of Japan?
Your answer should be very brief. -4.37e+11. In the year 2000, what is the difference between the Trade (in US$) in Bangladesh and Trade (in US$) in Kenya?
Your answer should be very brief. 5.03e+09. In the year 2000, what is the difference between the Trade (in US$) in Faeroe Islands and Trade (in US$) in Japan?
Keep it short and to the point. -4.45e+11. In the year 2000, what is the difference between the Trade (in US$) of Faeroe Islands and Trade (in US$) of Kenya?
Give a very brief answer. -3.42e+09. In the year 2000, what is the difference between the Trade (in US$) in Japan and Trade (in US$) in Kenya?
Your answer should be compact. 4.42e+11. In the year 2001, what is the difference between the Trade (in US$) of Bangladesh and Trade (in US$) of Faeroe Islands?
Your answer should be compact. 9.52e+09. In the year 2001, what is the difference between the Trade (in US$) of Bangladesh and Trade (in US$) of Japan?
Your answer should be compact. -3.98e+11. In the year 2001, what is the difference between the Trade (in US$) of Bangladesh and Trade (in US$) of Kenya?
Keep it short and to the point. 5.82e+09. In the year 2001, what is the difference between the Trade (in US$) of Faeroe Islands and Trade (in US$) of Japan?
Your response must be concise. -4.07e+11. In the year 2001, what is the difference between the Trade (in US$) in Faeroe Islands and Trade (in US$) in Kenya?
Offer a very short reply. -3.70e+09. In the year 2001, what is the difference between the Trade (in US$) in Japan and Trade (in US$) in Kenya?
Ensure brevity in your answer.  4.04e+11. In the year 2002, what is the difference between the Trade (in US$) in Bangladesh and Trade (in US$) in Faeroe Islands?
Offer a very short reply. 8.45e+09. In the year 2002, what is the difference between the Trade (in US$) of Bangladesh and Trade (in US$) of Japan?
Provide a succinct answer. -3.85e+11. In the year 2002, what is the difference between the Trade (in US$) of Bangladesh and Trade (in US$) of Kenya?
Offer a very short reply. 5.08e+09. In the year 2002, what is the difference between the Trade (in US$) of Faeroe Islands and Trade (in US$) of Japan?
Offer a terse response. -3.94e+11. In the year 2002, what is the difference between the Trade (in US$) of Faeroe Islands and Trade (in US$) of Kenya?
Keep it short and to the point. -3.37e+09. In the year 2002, what is the difference between the Trade (in US$) in Japan and Trade (in US$) in Kenya?
Make the answer very short. 3.91e+11. In the year 2003, what is the difference between the Trade (in US$) of Bangladesh and Trade (in US$) of Faeroe Islands?
Give a very brief answer. 8.89e+09. In the year 2003, what is the difference between the Trade (in US$) of Bangladesh and Trade (in US$) of Japan?
Offer a terse response. -4.30e+11. In the year 2003, what is the difference between the Trade (in US$) in Bangladesh and Trade (in US$) in Kenya?
Make the answer very short. 5.28e+09. In the year 2003, what is the difference between the Trade (in US$) in Faeroe Islands and Trade (in US$) in Japan?
Offer a very short reply. -4.39e+11. In the year 2003, what is the difference between the Trade (in US$) of Faeroe Islands and Trade (in US$) of Kenya?
Your answer should be very brief. -3.61e+09. In the year 2003, what is the difference between the Trade (in US$) in Japan and Trade (in US$) in Kenya?
Provide a short and direct response. 4.35e+11. In the year 2004, what is the difference between the Trade (in US$) in Bangladesh and Trade (in US$) in Faeroe Islands?
Offer a very short reply. 9.46e+09. In the year 2004, what is the difference between the Trade (in US$) in Bangladesh and Trade (in US$) in Japan?
Provide a short and direct response. -5.14e+11. In the year 2004, what is the difference between the Trade (in US$) in Bangladesh and Trade (in US$) in Kenya?
Your response must be concise. 4.94e+09. In the year 2004, what is the difference between the Trade (in US$) of Faeroe Islands and Trade (in US$) of Japan?
Provide a succinct answer. -5.23e+11. In the year 2004, what is the difference between the Trade (in US$) in Faeroe Islands and Trade (in US$) in Kenya?
Make the answer very short. -4.52e+09. In the year 2004, what is the difference between the Trade (in US$) in Japan and Trade (in US$) in Kenya?
Your answer should be compact. 5.19e+11. In the year 2005, what is the difference between the Trade (in US$) in Bangladesh and Trade (in US$) in Faeroe Islands?
Your response must be concise. 1.30e+1. In the year 2005, what is the difference between the Trade (in US$) in Bangladesh and Trade (in US$) in Japan?
Give a very brief answer. -5.76e+11. In the year 2005, what is the difference between the Trade (in US$) of Bangladesh and Trade (in US$) of Kenya?
Your response must be concise. 7.15e+09. In the year 2005, what is the difference between the Trade (in US$) of Faeroe Islands and Trade (in US$) of Japan?
Provide a short and direct response. -5.89e+11. In the year 2005, what is the difference between the Trade (in US$) of Faeroe Islands and Trade (in US$) of Kenya?
Provide a succinct answer. -5.83e+09. In the year 2005, what is the difference between the Trade (in US$) in Japan and Trade (in US$) in Kenya?
Provide a succinct answer. 5.83e+11. In the year 2006, what is the difference between the Trade (in US$) in Bangladesh and Trade (in US$) in Faeroe Islands?
Provide a succinct answer. 1.46e+1. In the year 2006, what is the difference between the Trade (in US$) of Bangladesh and Trade (in US$) of Japan?
Make the answer very short. -6.34e+11. In the year 2006, what is the difference between the Trade (in US$) in Bangladesh and Trade (in US$) in Kenya?
Make the answer very short. 7.30e+09. In the year 2006, what is the difference between the Trade (in US$) in Faeroe Islands and Trade (in US$) in Japan?
Give a very brief answer. -6.49e+11. In the year 2006, what is the difference between the Trade (in US$) of Faeroe Islands and Trade (in US$) of Kenya?
Ensure brevity in your answer.  -7.30e+09. In the year 2006, what is the difference between the Trade (in US$) of Japan and Trade (in US$) of Kenya?
Keep it short and to the point. 6.41e+11. What is the ratio of the Trade (in US$) in Bangladesh in 1999 to that in 2000?
Make the answer very short. 0.94. What is the ratio of the Trade (in US$) of Faeroe Islands in 1999 to that in 2000?
Offer a terse response. 0.92. What is the ratio of the Trade (in US$) in Japan in 1999 to that in 2000?
Provide a short and direct response. 0.85. What is the ratio of the Trade (in US$) in Kenya in 1999 to that in 2000?
Provide a short and direct response. 0.88. What is the ratio of the Trade (in US$) in Bangladesh in 1999 to that in 2001?
Your response must be concise. 0.84. What is the ratio of the Trade (in US$) of Faeroe Islands in 1999 to that in 2001?
Offer a terse response. 0.96. What is the ratio of the Trade (in US$) in Japan in 1999 to that in 2001?
Your answer should be compact. 0.93. What is the ratio of the Trade (in US$) in Kenya in 1999 to that in 2001?
Offer a terse response. 0.82. What is the ratio of the Trade (in US$) in Bangladesh in 1999 to that in 2002?
Offer a terse response. 0.94. What is the ratio of the Trade (in US$) in Faeroe Islands in 1999 to that in 2002?
Provide a succinct answer. 0.92. What is the ratio of the Trade (in US$) of Kenya in 1999 to that in 2002?
Offer a terse response. 0.89. What is the ratio of the Trade (in US$) of Bangladesh in 1999 to that in 2003?
Offer a terse response. 0.87. What is the ratio of the Trade (in US$) of Faeroe Islands in 1999 to that in 2003?
Your answer should be very brief. 0.64. What is the ratio of the Trade (in US$) in Japan in 1999 to that in 2003?
Ensure brevity in your answer.  0.87. What is the ratio of the Trade (in US$) in Kenya in 1999 to that in 2003?
Ensure brevity in your answer.  0.79. What is the ratio of the Trade (in US$) in Bangladesh in 1999 to that in 2004?
Offer a terse response. 0.83. What is the ratio of the Trade (in US$) of Faeroe Islands in 1999 to that in 2004?
Give a very brief answer. 0.73. What is the ratio of the Trade (in US$) of Japan in 1999 to that in 2004?
Offer a very short reply. 0.73. What is the ratio of the Trade (in US$) in Kenya in 1999 to that in 2004?
Offer a very short reply. 0.67. What is the ratio of the Trade (in US$) in Bangladesh in 1999 to that in 2005?
Make the answer very short. 0.61. What is the ratio of the Trade (in US$) in Faeroe Islands in 1999 to that in 2005?
Make the answer very short. 0.62. What is the ratio of the Trade (in US$) in Japan in 1999 to that in 2005?
Give a very brief answer. 0.64. What is the ratio of the Trade (in US$) of Kenya in 1999 to that in 2005?
Provide a succinct answer. 0.52. What is the ratio of the Trade (in US$) in Bangladesh in 1999 to that in 2006?
Provide a succinct answer. 0.55. What is the ratio of the Trade (in US$) in Faeroe Islands in 1999 to that in 2006?
Provide a succinct answer. 0.55. What is the ratio of the Trade (in US$) of Japan in 1999 to that in 2006?
Your answer should be very brief. 0.59. What is the ratio of the Trade (in US$) of Kenya in 1999 to that in 2006?
Make the answer very short. 0.42. What is the ratio of the Trade (in US$) in Bangladesh in 2000 to that in 2001?
Provide a succinct answer. 0.9. What is the ratio of the Trade (in US$) in Faeroe Islands in 2000 to that in 2001?
Provide a succinct answer. 1.05. What is the ratio of the Trade (in US$) in Japan in 2000 to that in 2001?
Provide a succinct answer. 1.09. What is the ratio of the Trade (in US$) in Japan in 2000 to that in 2002?
Your response must be concise. 1.13. What is the ratio of the Trade (in US$) of Kenya in 2000 to that in 2002?
Your response must be concise. 1.01. What is the ratio of the Trade (in US$) of Bangladesh in 2000 to that in 2003?
Keep it short and to the point. 0.93. What is the ratio of the Trade (in US$) in Faeroe Islands in 2000 to that in 2003?
Give a very brief answer. 0.7. What is the ratio of the Trade (in US$) in Japan in 2000 to that in 2003?
Give a very brief answer. 1.01. What is the ratio of the Trade (in US$) of Bangladesh in 2000 to that in 2004?
Make the answer very short. 0.89. What is the ratio of the Trade (in US$) in Faeroe Islands in 2000 to that in 2004?
Keep it short and to the point. 0.79. What is the ratio of the Trade (in US$) in Japan in 2000 to that in 2004?
Provide a short and direct response. 0.85. What is the ratio of the Trade (in US$) of Kenya in 2000 to that in 2004?
Provide a short and direct response. 0.76. What is the ratio of the Trade (in US$) in Bangladesh in 2000 to that in 2005?
Keep it short and to the point. 0.65. What is the ratio of the Trade (in US$) of Faeroe Islands in 2000 to that in 2005?
Keep it short and to the point. 0.67. What is the ratio of the Trade (in US$) of Japan in 2000 to that in 2005?
Offer a very short reply. 0.76. What is the ratio of the Trade (in US$) in Kenya in 2000 to that in 2005?
Your answer should be compact. 0.6. What is the ratio of the Trade (in US$) in Bangladesh in 2000 to that in 2006?
Your answer should be very brief. 0.58. What is the ratio of the Trade (in US$) in Faeroe Islands in 2000 to that in 2006?
Your answer should be compact. 0.6. What is the ratio of the Trade (in US$) of Japan in 2000 to that in 2006?
Make the answer very short. 0.69. What is the ratio of the Trade (in US$) of Kenya in 2000 to that in 2006?
Keep it short and to the point. 0.48. What is the ratio of the Trade (in US$) of Bangladesh in 2001 to that in 2002?
Provide a short and direct response. 1.11. What is the ratio of the Trade (in US$) in Faeroe Islands in 2001 to that in 2002?
Keep it short and to the point. 0.96. What is the ratio of the Trade (in US$) of Japan in 2001 to that in 2002?
Keep it short and to the point. 1.03. What is the ratio of the Trade (in US$) of Kenya in 2001 to that in 2002?
Offer a terse response. 1.08. What is the ratio of the Trade (in US$) of Bangladesh in 2001 to that in 2003?
Give a very brief answer. 1.03. What is the ratio of the Trade (in US$) in Faeroe Islands in 2001 to that in 2003?
Give a very brief answer. 0.67. What is the ratio of the Trade (in US$) in Japan in 2001 to that in 2003?
Your answer should be very brief. 0.93. What is the ratio of the Trade (in US$) of Kenya in 2001 to that in 2003?
Keep it short and to the point. 0.96. What is the ratio of the Trade (in US$) in Bangladesh in 2001 to that in 2004?
Your answer should be very brief. 0.99. What is the ratio of the Trade (in US$) in Faeroe Islands in 2001 to that in 2004?
Offer a terse response. 0.76. What is the ratio of the Trade (in US$) of Japan in 2001 to that in 2004?
Offer a very short reply. 0.78. What is the ratio of the Trade (in US$) of Kenya in 2001 to that in 2004?
Your answer should be very brief. 0.81. What is the ratio of the Trade (in US$) in Bangladesh in 2001 to that in 2005?
Offer a very short reply. 0.73. What is the ratio of the Trade (in US$) of Faeroe Islands in 2001 to that in 2005?
Your answer should be compact. 0.64. What is the ratio of the Trade (in US$) in Japan in 2001 to that in 2005?
Your response must be concise. 0.69. What is the ratio of the Trade (in US$) in Kenya in 2001 to that in 2005?
Your response must be concise. 0.64. What is the ratio of the Trade (in US$) of Bangladesh in 2001 to that in 2006?
Provide a succinct answer. 0.65. What is the ratio of the Trade (in US$) of Faeroe Islands in 2001 to that in 2006?
Keep it short and to the point. 0.57. What is the ratio of the Trade (in US$) of Japan in 2001 to that in 2006?
Your response must be concise. 0.63. What is the ratio of the Trade (in US$) of Kenya in 2001 to that in 2006?
Offer a very short reply. 0.51. What is the ratio of the Trade (in US$) of Bangladesh in 2002 to that in 2003?
Offer a terse response. 0.93. What is the ratio of the Trade (in US$) in Faeroe Islands in 2002 to that in 2003?
Provide a succinct answer. 0.7. What is the ratio of the Trade (in US$) of Japan in 2002 to that in 2003?
Give a very brief answer. 0.9. What is the ratio of the Trade (in US$) in Bangladesh in 2002 to that in 2004?
Offer a terse response. 0.89. What is the ratio of the Trade (in US$) of Faeroe Islands in 2002 to that in 2004?
Offer a very short reply. 0.79. What is the ratio of the Trade (in US$) in Japan in 2002 to that in 2004?
Offer a very short reply. 0.75. What is the ratio of the Trade (in US$) in Kenya in 2002 to that in 2004?
Provide a succinct answer. 0.75. What is the ratio of the Trade (in US$) in Bangladesh in 2002 to that in 2005?
Make the answer very short. 0.65. What is the ratio of the Trade (in US$) in Faeroe Islands in 2002 to that in 2005?
Keep it short and to the point. 0.67. What is the ratio of the Trade (in US$) of Japan in 2002 to that in 2005?
Keep it short and to the point. 0.67. What is the ratio of the Trade (in US$) of Kenya in 2002 to that in 2005?
Provide a succinct answer. 0.59. What is the ratio of the Trade (in US$) in Bangladesh in 2002 to that in 2006?
Offer a terse response. 0.58. What is the ratio of the Trade (in US$) of Faeroe Islands in 2002 to that in 2006?
Your response must be concise. 0.6. What is the ratio of the Trade (in US$) in Japan in 2002 to that in 2006?
Offer a very short reply. 0.61. What is the ratio of the Trade (in US$) of Kenya in 2002 to that in 2006?
Your answer should be very brief. 0.48. What is the ratio of the Trade (in US$) in Bangladesh in 2003 to that in 2004?
Your answer should be very brief. 0.95. What is the ratio of the Trade (in US$) of Faeroe Islands in 2003 to that in 2004?
Provide a succinct answer. 1.13. What is the ratio of the Trade (in US$) in Japan in 2003 to that in 2004?
Provide a succinct answer. 0.84. What is the ratio of the Trade (in US$) in Kenya in 2003 to that in 2004?
Provide a succinct answer. 0.85. What is the ratio of the Trade (in US$) of Bangladesh in 2003 to that in 2005?
Your response must be concise. 0.7. What is the ratio of the Trade (in US$) in Faeroe Islands in 2003 to that in 2005?
Offer a very short reply. 0.96. What is the ratio of the Trade (in US$) of Japan in 2003 to that in 2005?
Give a very brief answer. 0.75. What is the ratio of the Trade (in US$) of Kenya in 2003 to that in 2005?
Provide a succinct answer. 0.66. What is the ratio of the Trade (in US$) in Bangladesh in 2003 to that in 2006?
Provide a succinct answer. 0.62. What is the ratio of the Trade (in US$) of Faeroe Islands in 2003 to that in 2006?
Provide a succinct answer. 0.85. What is the ratio of the Trade (in US$) in Japan in 2003 to that in 2006?
Ensure brevity in your answer.  0.68. What is the ratio of the Trade (in US$) of Kenya in 2003 to that in 2006?
Make the answer very short. 0.54. What is the ratio of the Trade (in US$) of Bangladesh in 2004 to that in 2005?
Give a very brief answer. 0.74. What is the ratio of the Trade (in US$) in Faeroe Islands in 2004 to that in 2005?
Offer a very short reply. 0.85. What is the ratio of the Trade (in US$) in Japan in 2004 to that in 2005?
Give a very brief answer. 0.89. What is the ratio of the Trade (in US$) of Kenya in 2004 to that in 2005?
Keep it short and to the point. 0.78. What is the ratio of the Trade (in US$) in Bangladesh in 2004 to that in 2006?
Your response must be concise. 0.65. What is the ratio of the Trade (in US$) of Faeroe Islands in 2004 to that in 2006?
Offer a terse response. 0.75. What is the ratio of the Trade (in US$) in Japan in 2004 to that in 2006?
Provide a succinct answer. 0.81. What is the ratio of the Trade (in US$) in Kenya in 2004 to that in 2006?
Make the answer very short. 0.64. What is the ratio of the Trade (in US$) in Bangladesh in 2005 to that in 2006?
Provide a succinct answer. 0.89. What is the ratio of the Trade (in US$) of Faeroe Islands in 2005 to that in 2006?
Your answer should be compact. 0.89. What is the ratio of the Trade (in US$) of Japan in 2005 to that in 2006?
Offer a very short reply. 0.91. What is the ratio of the Trade (in US$) in Kenya in 2005 to that in 2006?
Offer a terse response. 0.81. What is the difference between the highest and the second highest Trade (in US$) in Bangladesh?
Offer a terse response. 1.74e+09. What is the difference between the highest and the second highest Trade (in US$) in Faeroe Islands?
Your answer should be very brief. 1.17e+08. What is the difference between the highest and the second highest Trade (in US$) of Japan?
Offer a terse response. 5.98e+1. What is the difference between the highest and the second highest Trade (in US$) of Kenya?
Provide a short and direct response. 1.59e+09. What is the difference between the highest and the lowest Trade (in US$) in Bangladesh?
Give a very brief answer. 7.10e+09. What is the difference between the highest and the lowest Trade (in US$) in Faeroe Islands?
Ensure brevity in your answer.  4.66e+08. What is the difference between the highest and the lowest Trade (in US$) in Japan?
Provide a short and direct response. 2.69e+11. What is the difference between the highest and the lowest Trade (in US$) in Kenya?
Provide a succinct answer. 4.80e+09. 